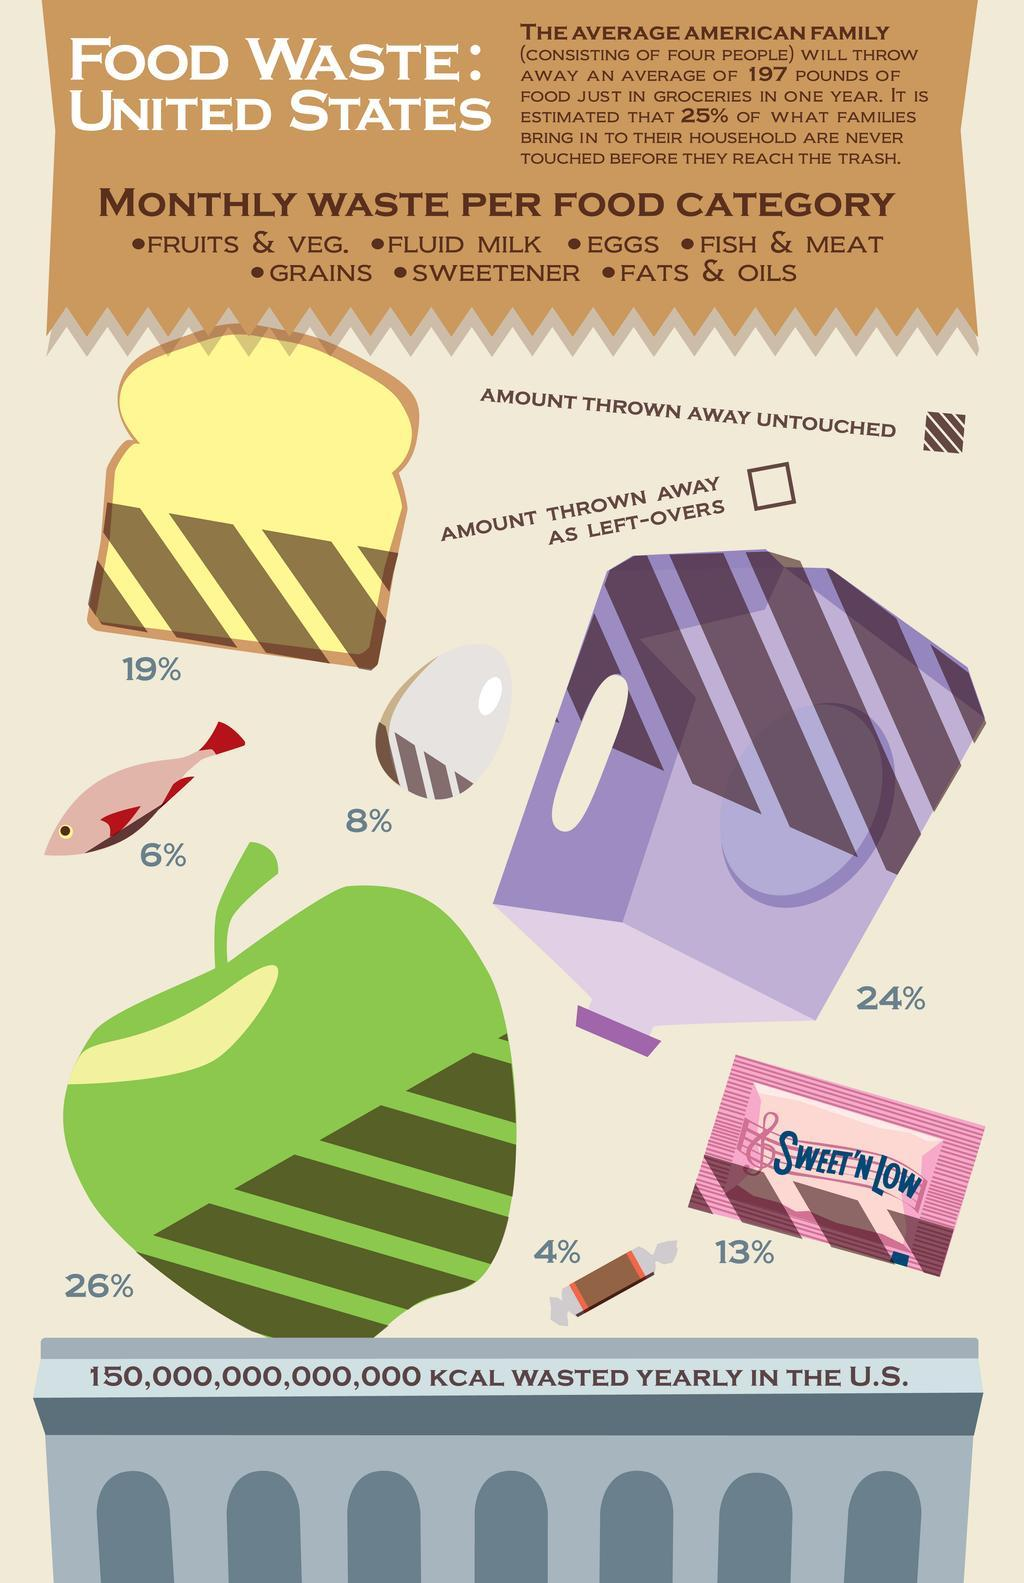Identify some key points in this picture. Approximately 76% of the milk produced is wasted as left-overs. According to a recent study, an estimated 19% of bread is thrown away untouched. The sweetener depicted in the infographic is SWEET'N LOW. Eight percent of food items are thrown away untouched, which includes milk, eggs, and fish. 